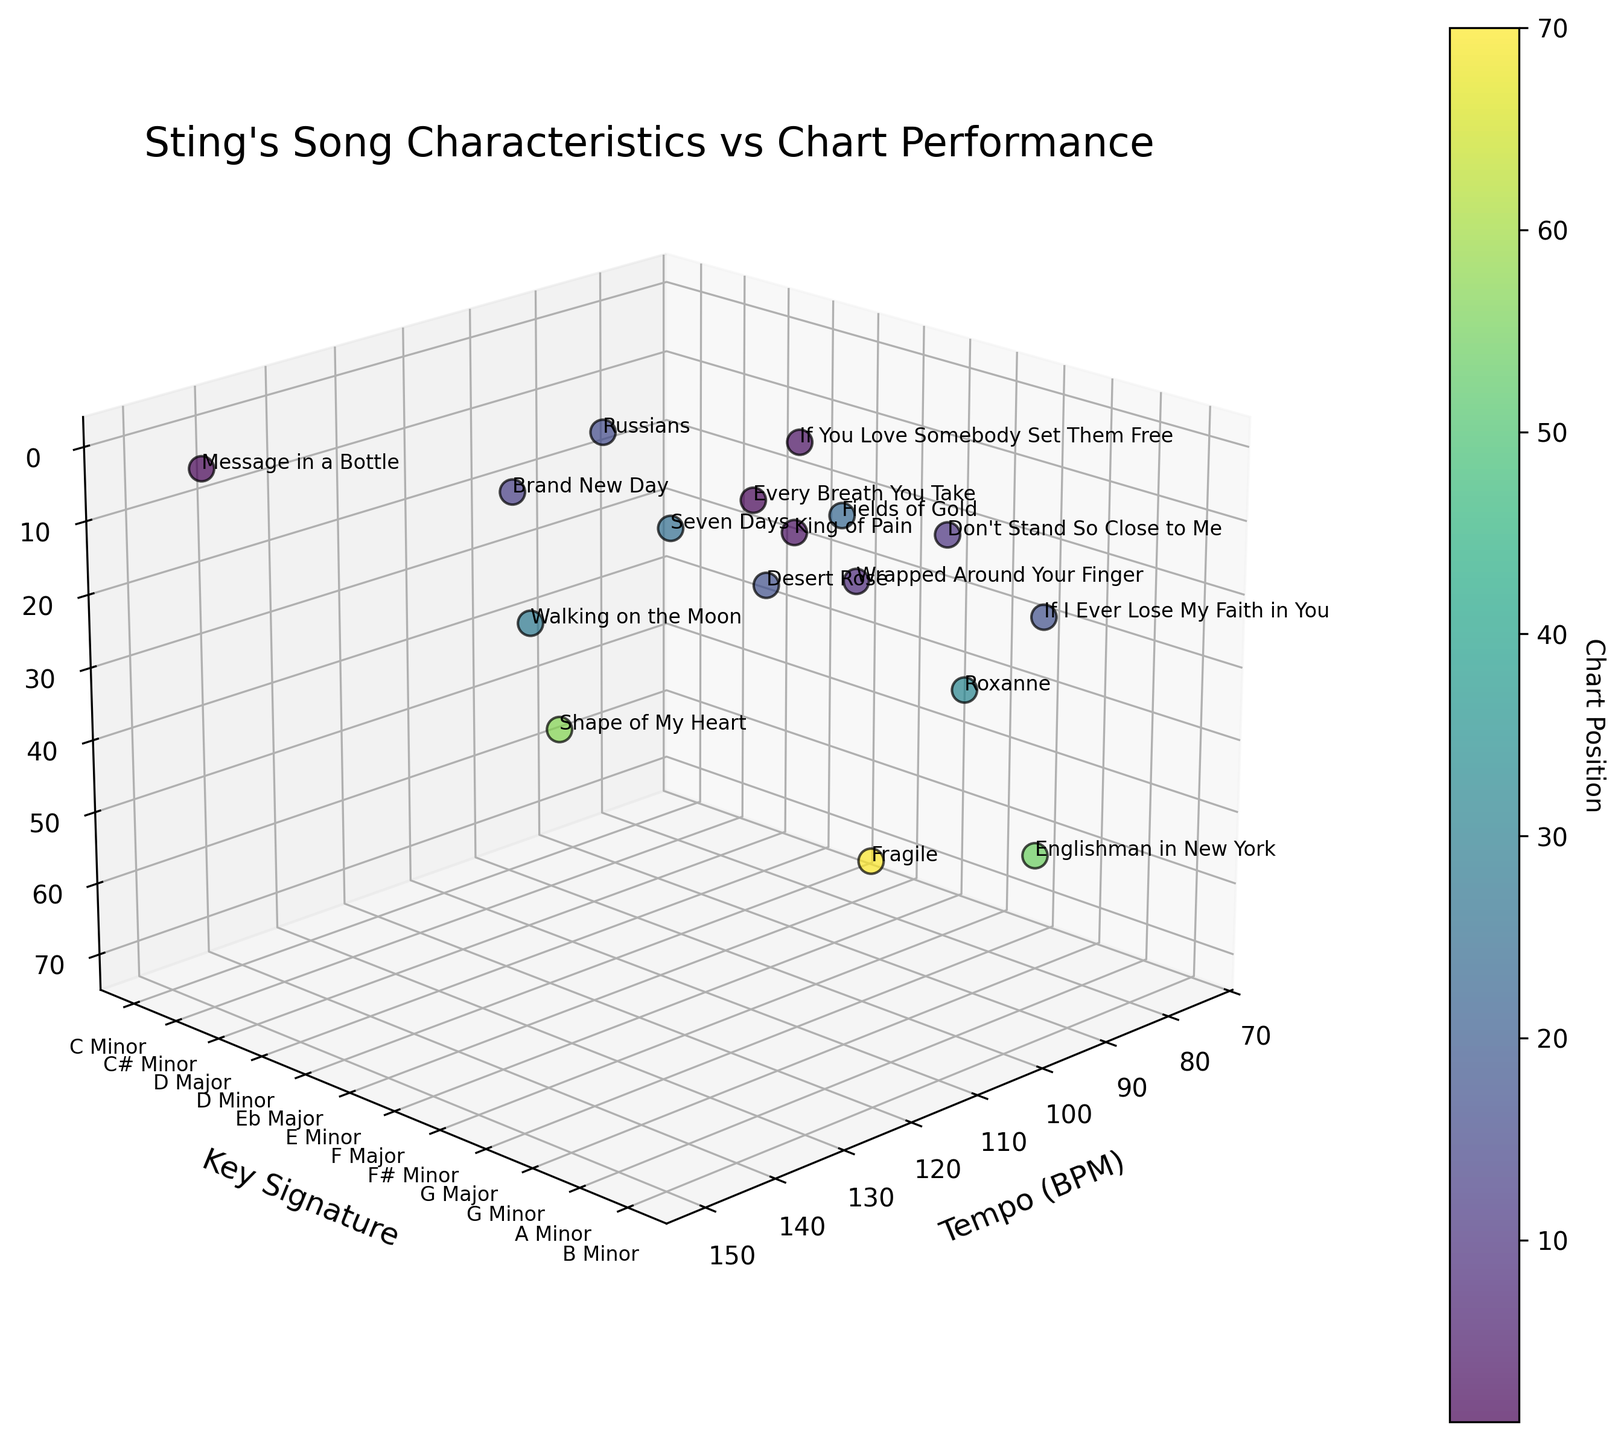What is the title of the figure? The title is usually located at the top of the figure. In this case, it is "Sting's Song Characteristics vs Chart Performance".
Answer: "Sting's Song Characteristics vs Chart Performance" What is the tempo range of the songs in the plot? The tempo range is determined by looking at the x-axis. The songs range from the lowest BPM (75) to the highest BPM (150).
Answer: 75 to 150 BPM Which song has the highest chart position and what is its tempo and key signature? The highest chart position is the number 1, as indicated by the top of the inverted z-axis. The songs with a chart position of 1 are "Every Breath You Take" (117 BPM, G Major) and "Message in a Bottle" (150 BPM, C# Minor).
Answer: "Every Breath You Take" and "Message in a Bottle" Is there any song in C# Minor? If so, what is its chart position? Each color represents a different chart position, and the y-axis represents key signatures. Identify the point at C# Minor (mapped value 1 on the y-axis). "Message in a Bottle" is in C# Minor with a chart position of 1.
Answer: Yes, chart position 1 What is the average chart position for songs in minor keys? Look at the y-axis for minor key values (A Minor, B Minor, C Minor, C# Minor, D Minor, E Minor, F# Minor, G Minor). The chart positions for these songs are 54, 57, 17, 1, 16, 70, and 32. Calculate (54+57+17+1+16+70+32)/7.
Answer: 35.29 Which key signature appears most frequently among these songs and what are their chart positions? Check the y-axis labels and count each occurrence. G Minor appears most frequently with chart positions of 32, 10, and 3.
Answer: G Minor, 32, 10, and 3 Are there more songs in major keys or minor keys? Count the data points for both categories. Major keys: Eb Major (1), G Major (1), D Major (2), F Major (1) = 5. Minor keys: A Minor (2), B Minor (1), C Minor (2), C# Minor (1), D Minor (1), E Minor (1), F# Minor (1), G Minor (3) = 12.
Answer: More songs in minor keys Which song has the lowest tempo and what is its key signature and chart position? Find the lowest value on the x-axis, which is 75 BPM. The corresponding song is "Fields of Gold" in Eb Major with a chart position of 23.
Answer: "Fields of Gold", Eb Major, 23 Is there any visible trend between song tempo and chart performance? To identify a trend, observe the distribution of data points along the tempo (x-axis) and chart position (z-axis). There is no distinct trend; songs with a wide range of tempos have varying chart positions.
Answer: No clear trend What is the median chart position of songs with a tempo between 90 and 120 BPM? Identify songs within the tempo range 90-120 BPM: "Shape of My Heart" (57), "If I Ever Lose My Faith in You" (17), "Brand New Day" (13), "Roxanne" (32), "Walking on the Moon" (28), "Don't Stand So Close to Me" (10), "King of Pain" (3), "Wrapped Around Your Finger" (8). Median is (3+8+10+13+17+28+32+57)/8 = Median is 15.
Answer: 15 